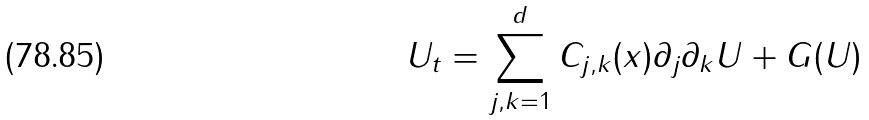<formula> <loc_0><loc_0><loc_500><loc_500>U _ { t } = \sum _ { j , k = 1 } ^ { d } C _ { j , k } ( x ) \partial _ { j } \partial _ { k } U + G ( U )</formula> 